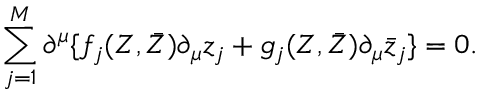Convert formula to latex. <formula><loc_0><loc_0><loc_500><loc_500>\sum _ { j = 1 } ^ { M } \partial ^ { \mu } \{ f _ { j } ( Z , \bar { Z } ) \partial _ { \mu } z _ { j } + g _ { j } ( Z , \bar { Z } ) \partial _ { \mu } \bar { z } _ { j } \} = 0 .</formula> 